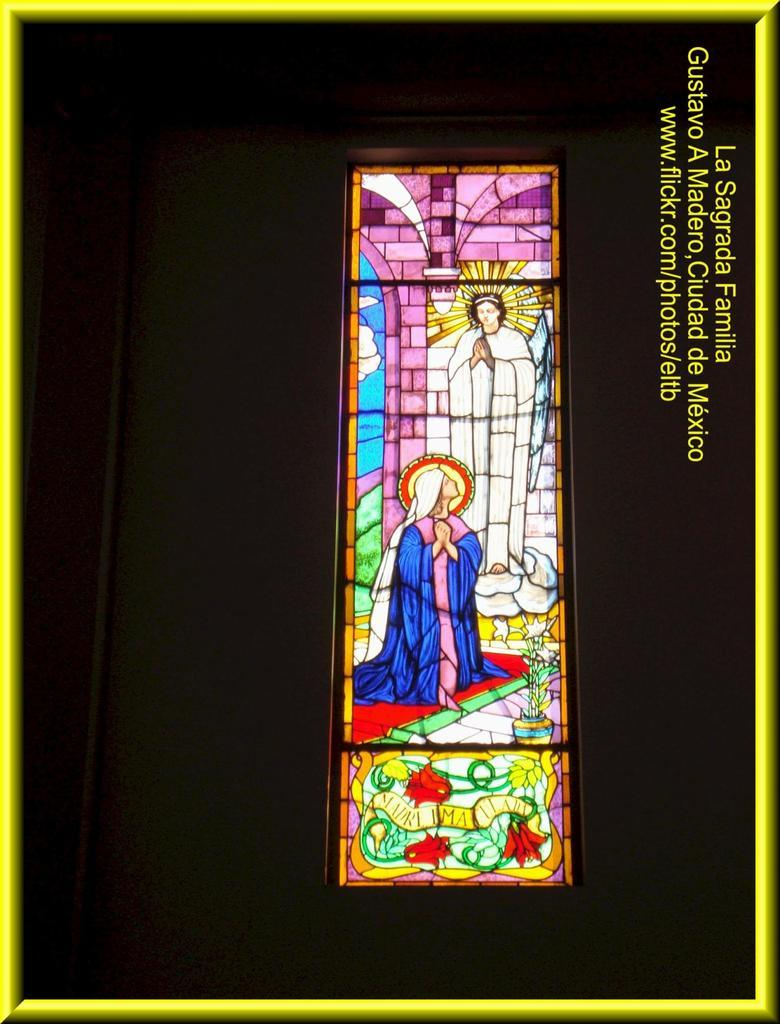What is the main subject of the image? There is a portrait in the center of the image. How much does the price of the bushes affect the fold of the portrait in the image? There are no bushes or prices mentioned in the image, and the portrait is not depicted as having folds. 